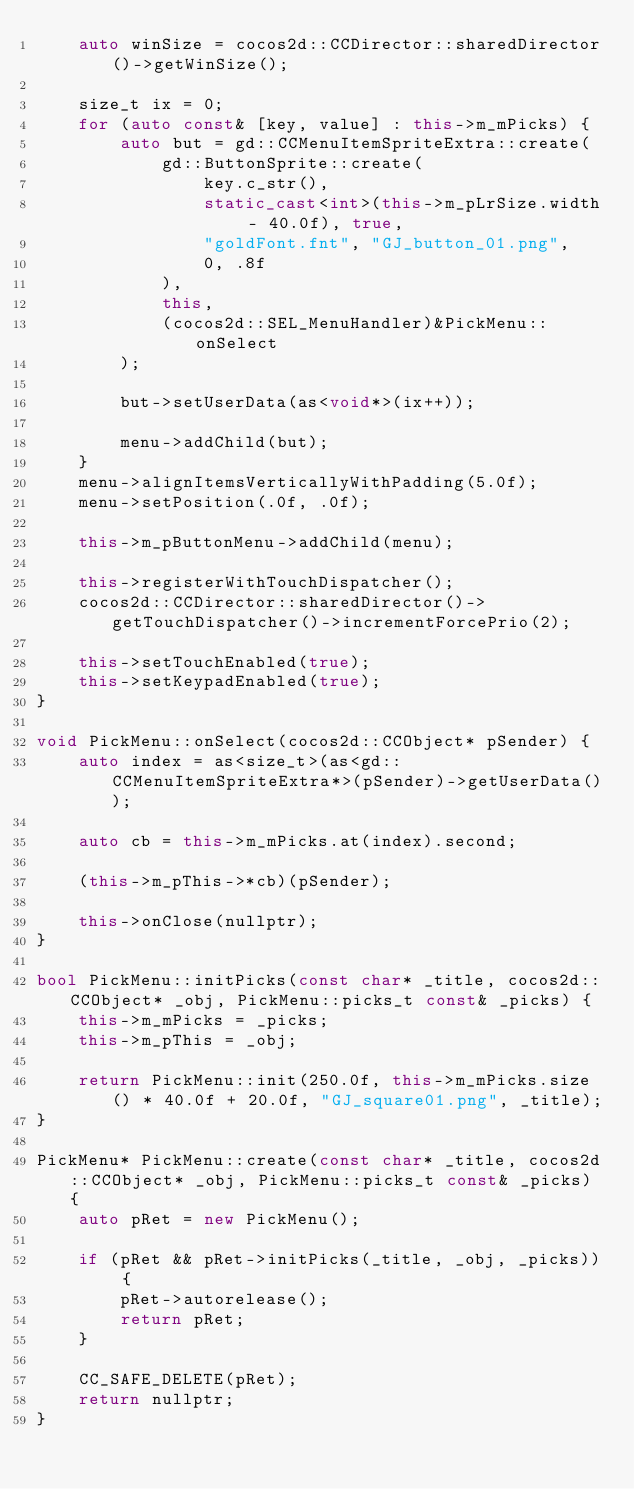<code> <loc_0><loc_0><loc_500><loc_500><_C++_>    auto winSize = cocos2d::CCDirector::sharedDirector()->getWinSize();

    size_t ix = 0;
    for (auto const& [key, value] : this->m_mPicks) {
        auto but = gd::CCMenuItemSpriteExtra::create(
            gd::ButtonSprite::create(
                key.c_str(),
                static_cast<int>(this->m_pLrSize.width - 40.0f), true,
                "goldFont.fnt", "GJ_button_01.png",
                0, .8f
            ),
            this,
            (cocos2d::SEL_MenuHandler)&PickMenu::onSelect
        );

        but->setUserData(as<void*>(ix++));

        menu->addChild(but);
    }
    menu->alignItemsVerticallyWithPadding(5.0f);
    menu->setPosition(.0f, .0f);

    this->m_pButtonMenu->addChild(menu);
    
    this->registerWithTouchDispatcher();
    cocos2d::CCDirector::sharedDirector()->getTouchDispatcher()->incrementForcePrio(2);

    this->setTouchEnabled(true);
    this->setKeypadEnabled(true);
}

void PickMenu::onSelect(cocos2d::CCObject* pSender) {
    auto index = as<size_t>(as<gd::CCMenuItemSpriteExtra*>(pSender)->getUserData());

    auto cb = this->m_mPicks.at(index).second;

    (this->m_pThis->*cb)(pSender);

    this->onClose(nullptr);
}

bool PickMenu::initPicks(const char* _title, cocos2d::CCObject* _obj, PickMenu::picks_t const& _picks) {
    this->m_mPicks = _picks;
    this->m_pThis = _obj;

    return PickMenu::init(250.0f, this->m_mPicks.size() * 40.0f + 20.0f, "GJ_square01.png", _title);
}

PickMenu* PickMenu::create(const char* _title, cocos2d::CCObject* _obj, PickMenu::picks_t const& _picks) {
    auto pRet = new PickMenu();

    if (pRet && pRet->initPicks(_title, _obj, _picks)) {
        pRet->autorelease();
        return pRet;
    }

    CC_SAFE_DELETE(pRet);
    return nullptr;
}
</code> 